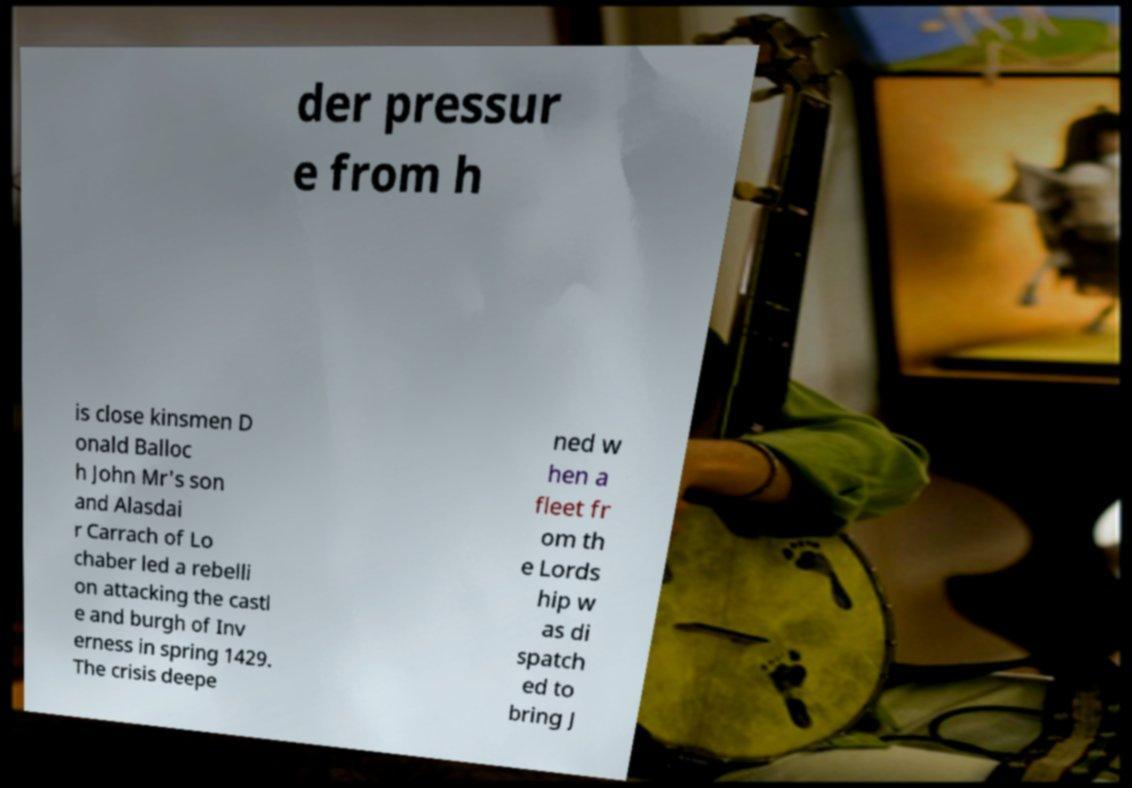I need the written content from this picture converted into text. Can you do that? der pressur e from h is close kinsmen D onald Balloc h John Mr's son and Alasdai r Carrach of Lo chaber led a rebelli on attacking the castl e and burgh of Inv erness in spring 1429. The crisis deepe ned w hen a fleet fr om th e Lords hip w as di spatch ed to bring J 